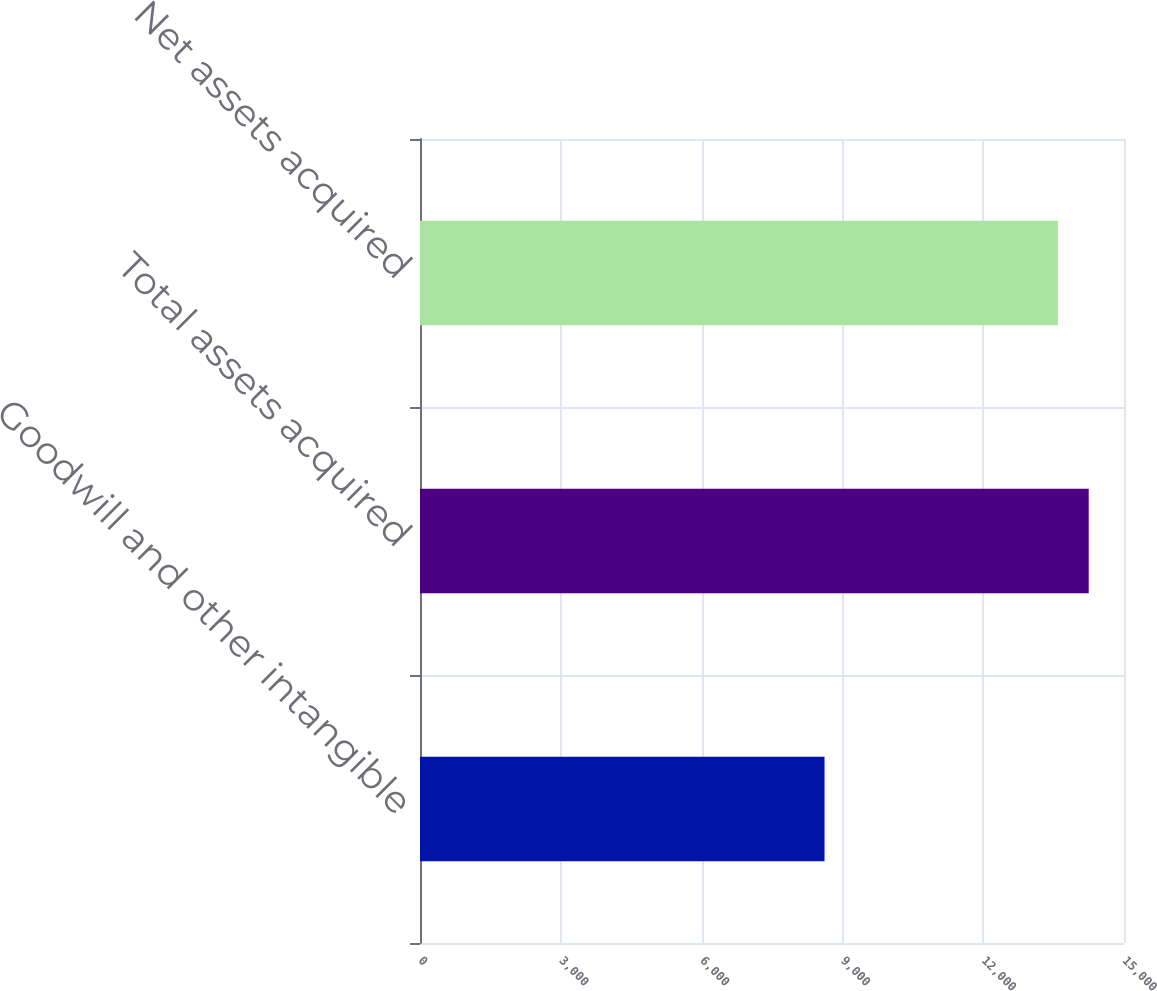Convert chart to OTSL. <chart><loc_0><loc_0><loc_500><loc_500><bar_chart><fcel>Goodwill and other intangible<fcel>Total assets acquired<fcel>Net assets acquired<nl><fcel>8619<fcel>14248<fcel>13591<nl></chart> 